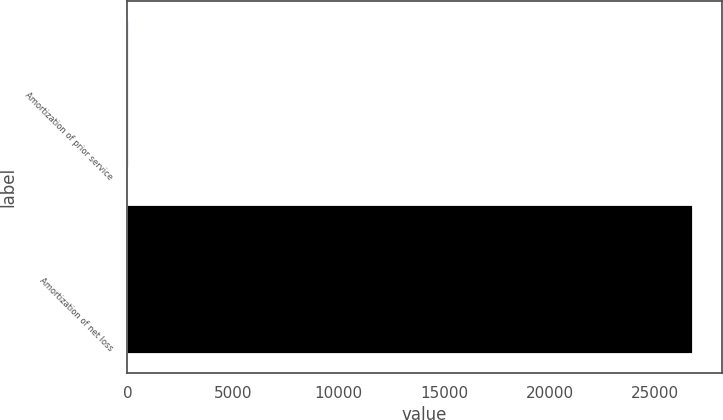Convert chart to OTSL. <chart><loc_0><loc_0><loc_500><loc_500><bar_chart><fcel>Amortization of prior service<fcel>Amortization of net loss<nl><fcel>77<fcel>26816<nl></chart> 